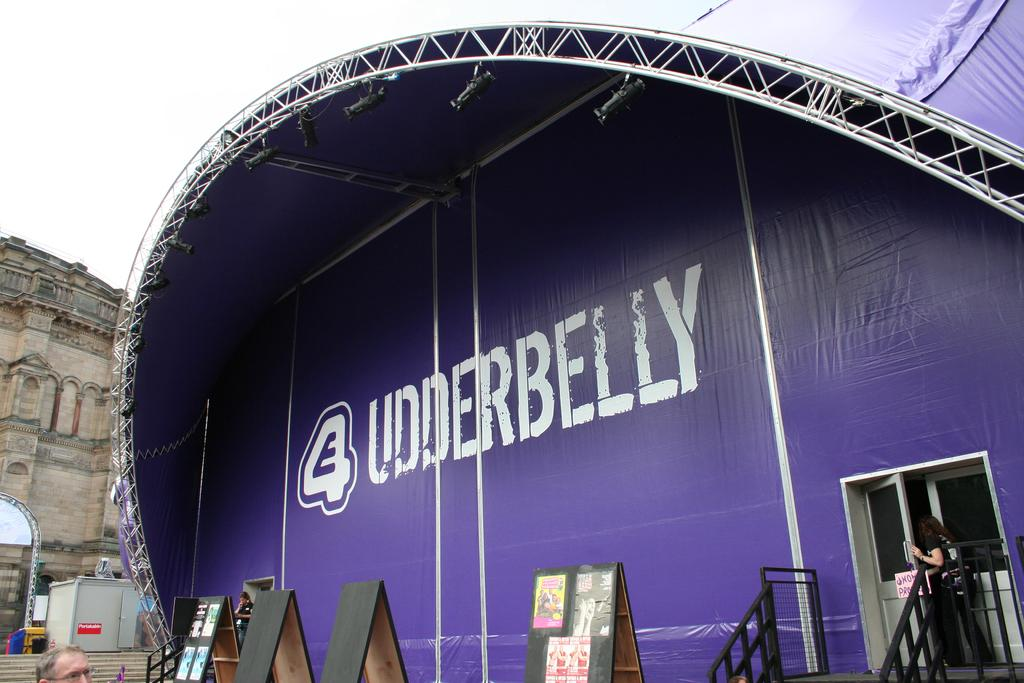How many people are in the image? There are people in the image, but the exact number cannot be determined from the provided facts. What can be seen near the people in the image? There are railings, a door, a banner, lights, rods, and boards visible in the image. What is in the background of the image? In the background of the image, there is a wall, a box, other objects, steps, and sky visible. What type of quill is being used to write on the cactus in the image? There is no quill or cactus present in the image. What kind of joke is being told by the people in the image? There is no indication of a joke being told in the image. 